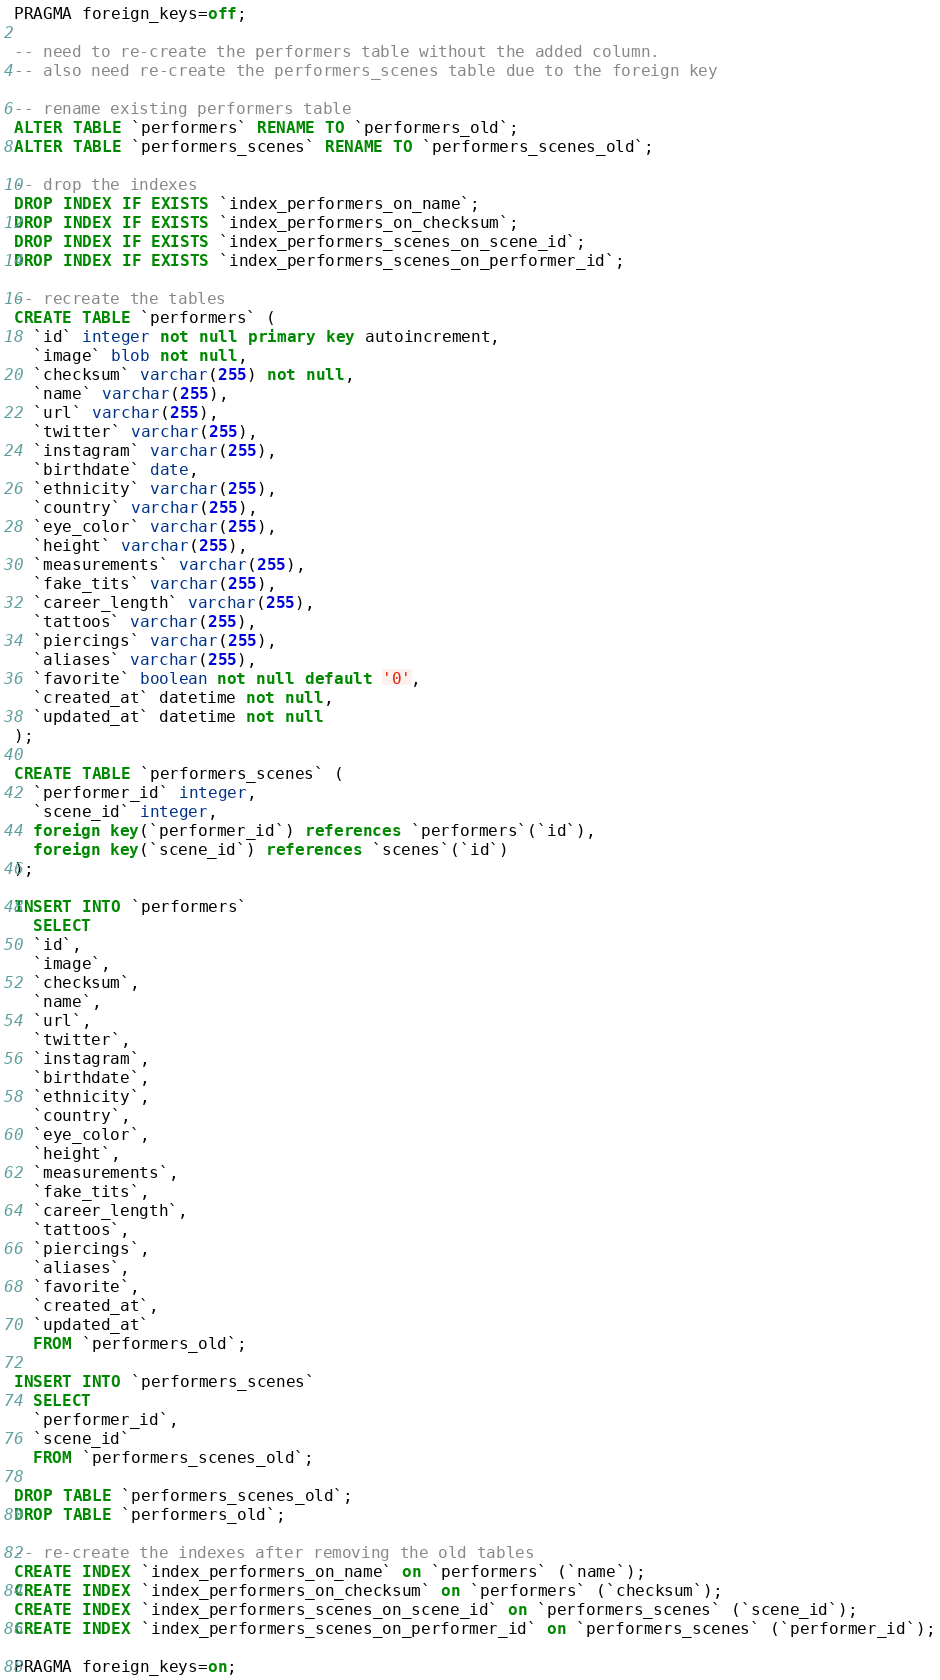<code> <loc_0><loc_0><loc_500><loc_500><_SQL_>
PRAGMA foreign_keys=off;

-- need to re-create the performers table without the added column.
-- also need re-create the performers_scenes table due to the foreign key

-- rename existing performers table
ALTER TABLE `performers` RENAME TO `performers_old`;
ALTER TABLE `performers_scenes` RENAME TO `performers_scenes_old`;

-- drop the indexes
DROP INDEX IF EXISTS `index_performers_on_name`;
DROP INDEX IF EXISTS `index_performers_on_checksum`;
DROP INDEX IF EXISTS `index_performers_scenes_on_scene_id`;
DROP INDEX IF EXISTS `index_performers_scenes_on_performer_id`;

-- recreate the tables
CREATE TABLE `performers` (
  `id` integer not null primary key autoincrement,
  `image` blob not null,
  `checksum` varchar(255) not null,
  `name` varchar(255),
  `url` varchar(255),
  `twitter` varchar(255),
  `instagram` varchar(255),
  `birthdate` date,
  `ethnicity` varchar(255),
  `country` varchar(255),
  `eye_color` varchar(255),
  `height` varchar(255),
  `measurements` varchar(255),
  `fake_tits` varchar(255),
  `career_length` varchar(255),
  `tattoos` varchar(255),
  `piercings` varchar(255),
  `aliases` varchar(255),
  `favorite` boolean not null default '0',
  `created_at` datetime not null,
  `updated_at` datetime not null
);

CREATE TABLE `performers_scenes` (
  `performer_id` integer,
  `scene_id` integer,
  foreign key(`performer_id`) references `performers`(`id`),
  foreign key(`scene_id`) references `scenes`(`id`)
);

INSERT INTO `performers` 
  SELECT 
  `id`,
  `image`,
  `checksum`,
  `name`,
  `url`,
  `twitter`,
  `instagram`,
  `birthdate`,
  `ethnicity`,
  `country`,
  `eye_color`,
  `height`,
  `measurements`,
  `fake_tits`,
  `career_length`,
  `tattoos`,
  `piercings`,
  `aliases`,
  `favorite`,
  `created_at`,
  `updated_at`
  FROM `performers_old`;

INSERT INTO `performers_scenes`
  SELECT
  `performer_id`,
  `scene_id`
  FROM `performers_scenes_old`;

DROP TABLE `performers_scenes_old`;
DROP TABLE `performers_old`;

-- re-create the indexes after removing the old tables
CREATE INDEX `index_performers_on_name` on `performers` (`name`);
CREATE INDEX `index_performers_on_checksum` on `performers` (`checksum`);
CREATE INDEX `index_performers_scenes_on_scene_id` on `performers_scenes` (`scene_id`);
CREATE INDEX `index_performers_scenes_on_performer_id` on `performers_scenes` (`performer_id`);

PRAGMA foreign_keys=on;
</code> 